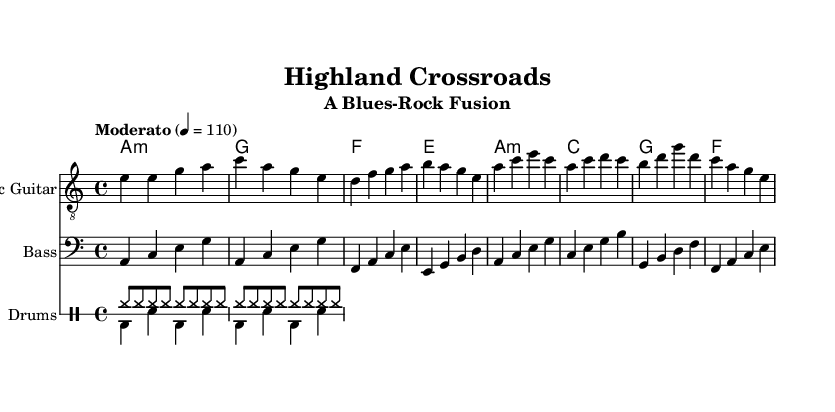What is the key signature of this music? The key signature is indicated at the beginning of the staff. Here, it shows one flat, which corresponds to the key of A minor.
Answer: A minor What is the time signature of this music? The time signature is located at the beginning of the staff. It shows '4/4', which means there are four beats per measure and the quarter note gets one beat.
Answer: 4/4 What is the tempo marking for this piece? The tempo marking is indicated above the staff in Italian. In this case, it states “Moderato” with a metronome marking of 110, meaning it should be played at a moderate speed.
Answer: Moderato How many sections are there in the music, based on the structure shown? The provided music consists of two main sections: the verse and the chorus. Each is identifiable by changes in melody and harmony backing.
Answer: Two Which instruments are included in this sheet music? The instruments are identified by the staff names at the left side of each staff. The sheet music includes Electric Guitar, Bass, and Drums.
Answer: Electric Guitar, Bass, Drums What type of bass line is used in this piece? The bass line is described in the music, and it appears to follow a "walking" style. This means it moves in a stepwise fashion, filling the measures with a typical rhythm for blues.
Answer: Walking bass line What is the primary chord used in the verse section? The primary chord is shown at the beginning of the verse section and is the first chord listed in the chord names, which is A minor.
Answer: A minor 